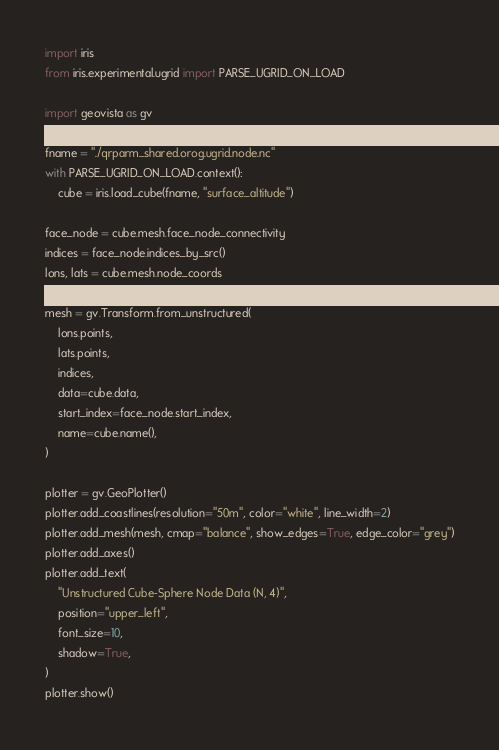<code> <loc_0><loc_0><loc_500><loc_500><_Python_>import iris
from iris.experimental.ugrid import PARSE_UGRID_ON_LOAD

import geovista as gv

fname = "./qrparm_shared.orog.ugrid.node.nc"
with PARSE_UGRID_ON_LOAD.context():
    cube = iris.load_cube(fname, "surface_altitude")

face_node = cube.mesh.face_node_connectivity
indices = face_node.indices_by_src()
lons, lats = cube.mesh.node_coords

mesh = gv.Transform.from_unstructured(
    lons.points,
    lats.points,
    indices,
    data=cube.data,
    start_index=face_node.start_index,
    name=cube.name(),
)

plotter = gv.GeoPlotter()
plotter.add_coastlines(resolution="50m", color="white", line_width=2)
plotter.add_mesh(mesh, cmap="balance", show_edges=True, edge_color="grey")
plotter.add_axes()
plotter.add_text(
    "Unstructured Cube-Sphere Node Data (N, 4)",
    position="upper_left",
    font_size=10,
    shadow=True,
)
plotter.show()
</code> 